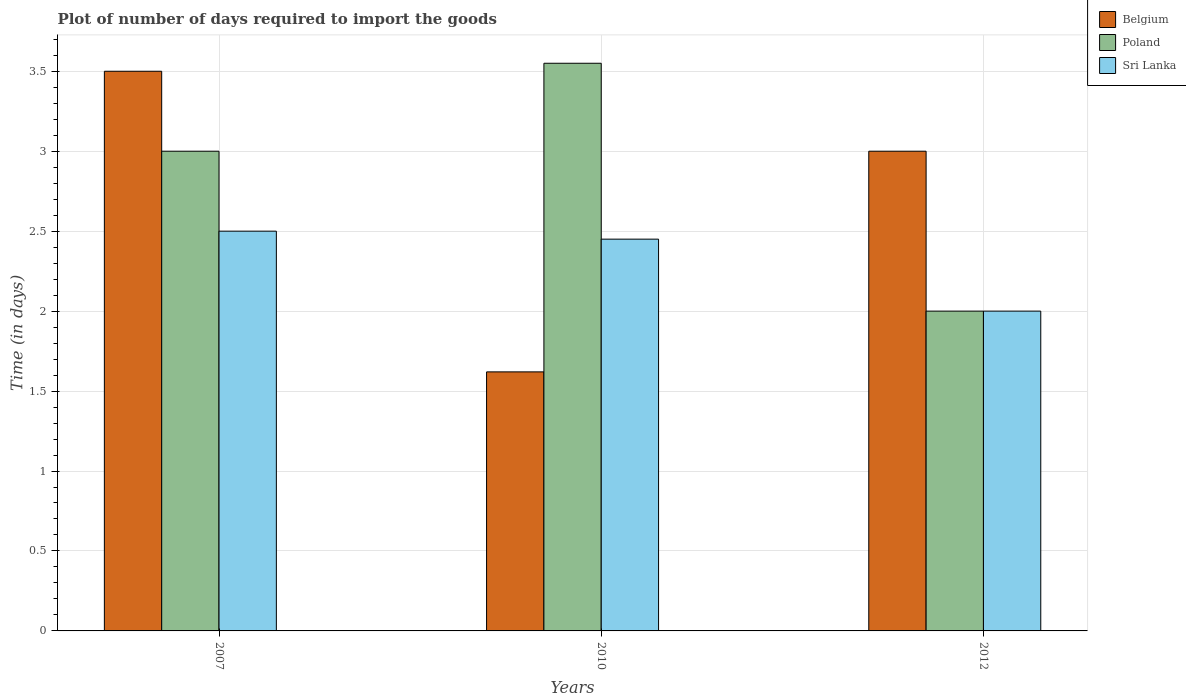How many groups of bars are there?
Your answer should be very brief. 3. Are the number of bars on each tick of the X-axis equal?
Your response must be concise. Yes. How many bars are there on the 2nd tick from the left?
Offer a terse response. 3. How many bars are there on the 3rd tick from the right?
Offer a very short reply. 3. Across all years, what is the minimum time required to import goods in Sri Lanka?
Your response must be concise. 2. In which year was the time required to import goods in Belgium minimum?
Provide a short and direct response. 2010. What is the total time required to import goods in Belgium in the graph?
Offer a terse response. 8.12. What is the difference between the time required to import goods in Sri Lanka in 2010 and that in 2012?
Provide a short and direct response. 0.45. What is the difference between the time required to import goods in Sri Lanka in 2007 and the time required to import goods in Poland in 2012?
Offer a very short reply. 0.5. What is the average time required to import goods in Belgium per year?
Your response must be concise. 2.71. In the year 2012, what is the difference between the time required to import goods in Belgium and time required to import goods in Sri Lanka?
Keep it short and to the point. 1. In how many years, is the time required to import goods in Poland greater than 2.3 days?
Make the answer very short. 2. What is the ratio of the time required to import goods in Belgium in 2007 to that in 2010?
Provide a succinct answer. 2.16. Is the time required to import goods in Sri Lanka in 2010 less than that in 2012?
Offer a terse response. No. What is the difference between the highest and the second highest time required to import goods in Sri Lanka?
Your answer should be very brief. 0.05. In how many years, is the time required to import goods in Sri Lanka greater than the average time required to import goods in Sri Lanka taken over all years?
Ensure brevity in your answer.  2. What does the 2nd bar from the left in 2010 represents?
Offer a terse response. Poland. Is it the case that in every year, the sum of the time required to import goods in Belgium and time required to import goods in Poland is greater than the time required to import goods in Sri Lanka?
Provide a succinct answer. Yes. How many bars are there?
Provide a succinct answer. 9. Are the values on the major ticks of Y-axis written in scientific E-notation?
Your answer should be compact. No. Does the graph contain grids?
Provide a short and direct response. Yes. Where does the legend appear in the graph?
Make the answer very short. Top right. How many legend labels are there?
Ensure brevity in your answer.  3. What is the title of the graph?
Your answer should be very brief. Plot of number of days required to import the goods. What is the label or title of the Y-axis?
Your response must be concise. Time (in days). What is the Time (in days) of Belgium in 2010?
Your answer should be very brief. 1.62. What is the Time (in days) of Poland in 2010?
Provide a short and direct response. 3.55. What is the Time (in days) in Sri Lanka in 2010?
Give a very brief answer. 2.45. What is the Time (in days) of Poland in 2012?
Make the answer very short. 2. Across all years, what is the maximum Time (in days) in Belgium?
Your response must be concise. 3.5. Across all years, what is the maximum Time (in days) in Poland?
Keep it short and to the point. 3.55. Across all years, what is the maximum Time (in days) in Sri Lanka?
Your answer should be very brief. 2.5. Across all years, what is the minimum Time (in days) in Belgium?
Your answer should be very brief. 1.62. Across all years, what is the minimum Time (in days) of Poland?
Keep it short and to the point. 2. What is the total Time (in days) in Belgium in the graph?
Ensure brevity in your answer.  8.12. What is the total Time (in days) of Poland in the graph?
Your answer should be very brief. 8.55. What is the total Time (in days) in Sri Lanka in the graph?
Keep it short and to the point. 6.95. What is the difference between the Time (in days) in Belgium in 2007 and that in 2010?
Your answer should be compact. 1.88. What is the difference between the Time (in days) in Poland in 2007 and that in 2010?
Offer a terse response. -0.55. What is the difference between the Time (in days) in Sri Lanka in 2007 and that in 2012?
Offer a very short reply. 0.5. What is the difference between the Time (in days) in Belgium in 2010 and that in 2012?
Keep it short and to the point. -1.38. What is the difference between the Time (in days) in Poland in 2010 and that in 2012?
Ensure brevity in your answer.  1.55. What is the difference between the Time (in days) of Sri Lanka in 2010 and that in 2012?
Offer a very short reply. 0.45. What is the difference between the Time (in days) of Belgium in 2007 and the Time (in days) of Sri Lanka in 2010?
Offer a very short reply. 1.05. What is the difference between the Time (in days) in Poland in 2007 and the Time (in days) in Sri Lanka in 2010?
Make the answer very short. 0.55. What is the difference between the Time (in days) of Belgium in 2007 and the Time (in days) of Poland in 2012?
Your answer should be compact. 1.5. What is the difference between the Time (in days) of Belgium in 2007 and the Time (in days) of Sri Lanka in 2012?
Make the answer very short. 1.5. What is the difference between the Time (in days) in Poland in 2007 and the Time (in days) in Sri Lanka in 2012?
Offer a very short reply. 1. What is the difference between the Time (in days) in Belgium in 2010 and the Time (in days) in Poland in 2012?
Make the answer very short. -0.38. What is the difference between the Time (in days) in Belgium in 2010 and the Time (in days) in Sri Lanka in 2012?
Your response must be concise. -0.38. What is the difference between the Time (in days) of Poland in 2010 and the Time (in days) of Sri Lanka in 2012?
Your answer should be compact. 1.55. What is the average Time (in days) of Belgium per year?
Provide a short and direct response. 2.71. What is the average Time (in days) of Poland per year?
Ensure brevity in your answer.  2.85. What is the average Time (in days) in Sri Lanka per year?
Your answer should be compact. 2.32. In the year 2007, what is the difference between the Time (in days) of Belgium and Time (in days) of Poland?
Your answer should be very brief. 0.5. In the year 2010, what is the difference between the Time (in days) of Belgium and Time (in days) of Poland?
Offer a very short reply. -1.93. In the year 2010, what is the difference between the Time (in days) in Belgium and Time (in days) in Sri Lanka?
Your answer should be very brief. -0.83. In the year 2010, what is the difference between the Time (in days) in Poland and Time (in days) in Sri Lanka?
Keep it short and to the point. 1.1. In the year 2012, what is the difference between the Time (in days) in Belgium and Time (in days) in Poland?
Your response must be concise. 1. In the year 2012, what is the difference between the Time (in days) of Belgium and Time (in days) of Sri Lanka?
Keep it short and to the point. 1. In the year 2012, what is the difference between the Time (in days) of Poland and Time (in days) of Sri Lanka?
Ensure brevity in your answer.  0. What is the ratio of the Time (in days) of Belgium in 2007 to that in 2010?
Provide a short and direct response. 2.16. What is the ratio of the Time (in days) of Poland in 2007 to that in 2010?
Provide a short and direct response. 0.85. What is the ratio of the Time (in days) of Sri Lanka in 2007 to that in 2010?
Keep it short and to the point. 1.02. What is the ratio of the Time (in days) of Sri Lanka in 2007 to that in 2012?
Keep it short and to the point. 1.25. What is the ratio of the Time (in days) in Belgium in 2010 to that in 2012?
Give a very brief answer. 0.54. What is the ratio of the Time (in days) of Poland in 2010 to that in 2012?
Provide a succinct answer. 1.77. What is the ratio of the Time (in days) in Sri Lanka in 2010 to that in 2012?
Your response must be concise. 1.23. What is the difference between the highest and the second highest Time (in days) in Belgium?
Offer a terse response. 0.5. What is the difference between the highest and the second highest Time (in days) in Poland?
Keep it short and to the point. 0.55. What is the difference between the highest and the lowest Time (in days) in Belgium?
Offer a very short reply. 1.88. What is the difference between the highest and the lowest Time (in days) in Poland?
Your response must be concise. 1.55. What is the difference between the highest and the lowest Time (in days) of Sri Lanka?
Provide a succinct answer. 0.5. 